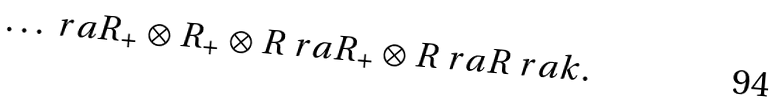Convert formula to latex. <formula><loc_0><loc_0><loc_500><loc_500>\dots \ r a R _ { + } \otimes R _ { + } \otimes R \ r a R _ { + } \otimes R \ r a R \ r a k .</formula> 